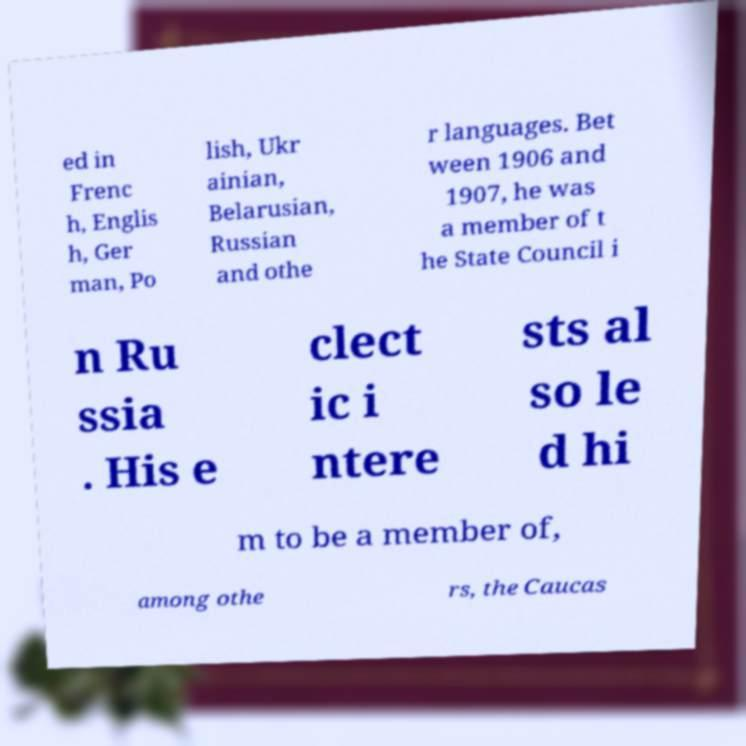For documentation purposes, I need the text within this image transcribed. Could you provide that? ed in Frenc h, Englis h, Ger man, Po lish, Ukr ainian, Belarusian, Russian and othe r languages. Bet ween 1906 and 1907, he was a member of t he State Council i n Ru ssia . His e clect ic i ntere sts al so le d hi m to be a member of, among othe rs, the Caucas 